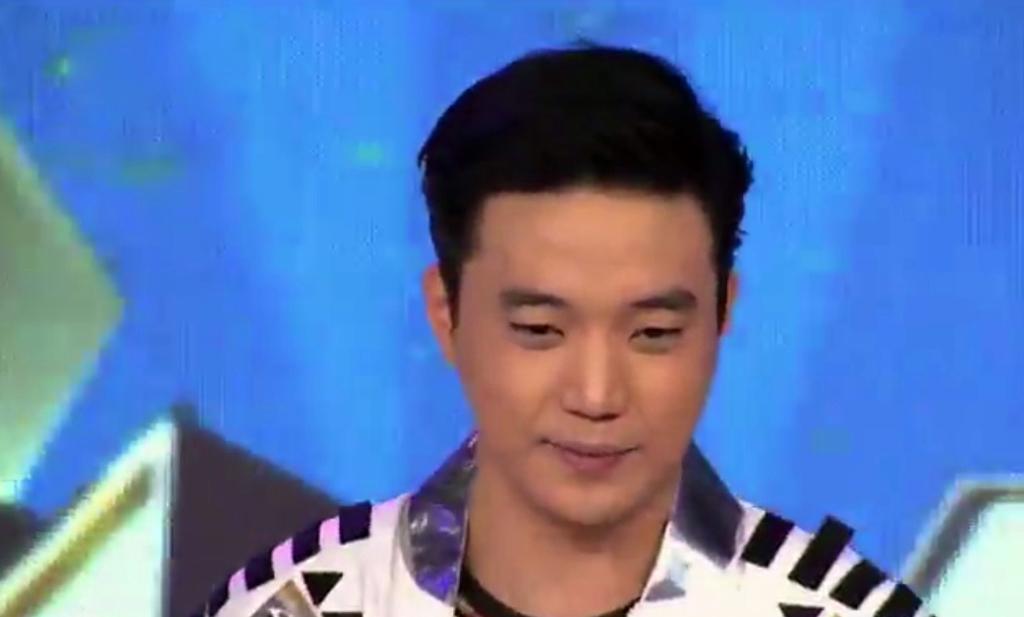In one or two sentences, can you explain what this image depicts? In this image I see a man who is wearing a jacket which is of white and black in color and it is blue in the background. 